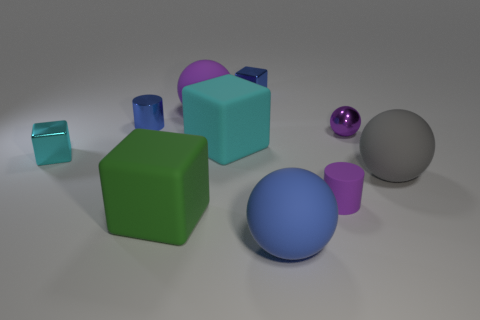How do the objects in the image compare in size? The objects vary in size, with the green cube being the largest and the small teal cube significantly smaller. The purple sphere is medium-sized, comparative to the others. 